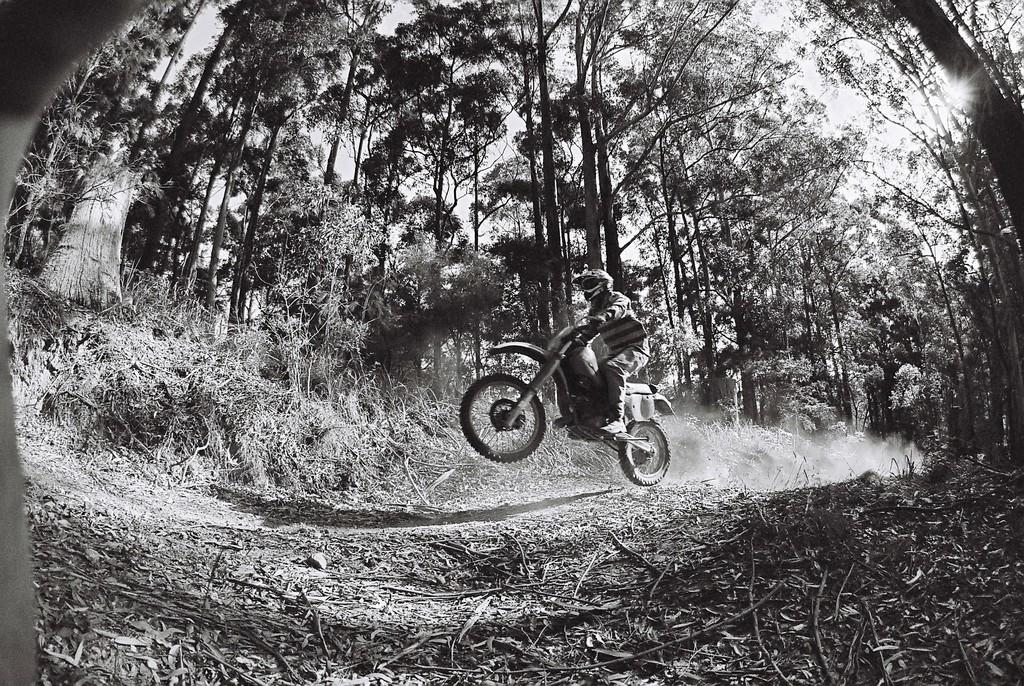What is the color scheme of the image? The image is black and white. What is the main subject of the image? There is a person riding a motorcycle in the image. What can be seen in the background of the image? There are trees visible in the background of the image. What type of brick structure can be seen in the image? There is no brick structure present in the image; it features a person riding a motorcycle with trees in the background. How many boxes are visible in the image? There are no boxes present in the image. 